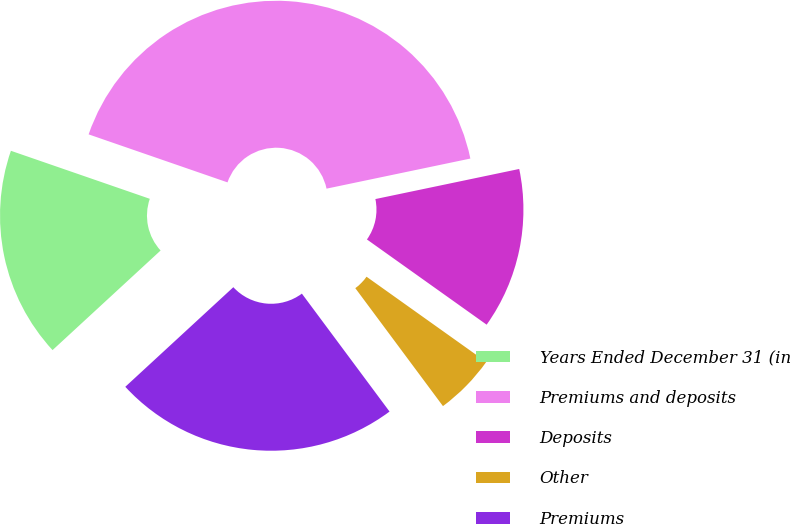<chart> <loc_0><loc_0><loc_500><loc_500><pie_chart><fcel>Years Ended December 31 (in<fcel>Premiums and deposits<fcel>Deposits<fcel>Other<fcel>Premiums<nl><fcel>17.15%<fcel>41.42%<fcel>13.13%<fcel>4.98%<fcel>23.32%<nl></chart> 